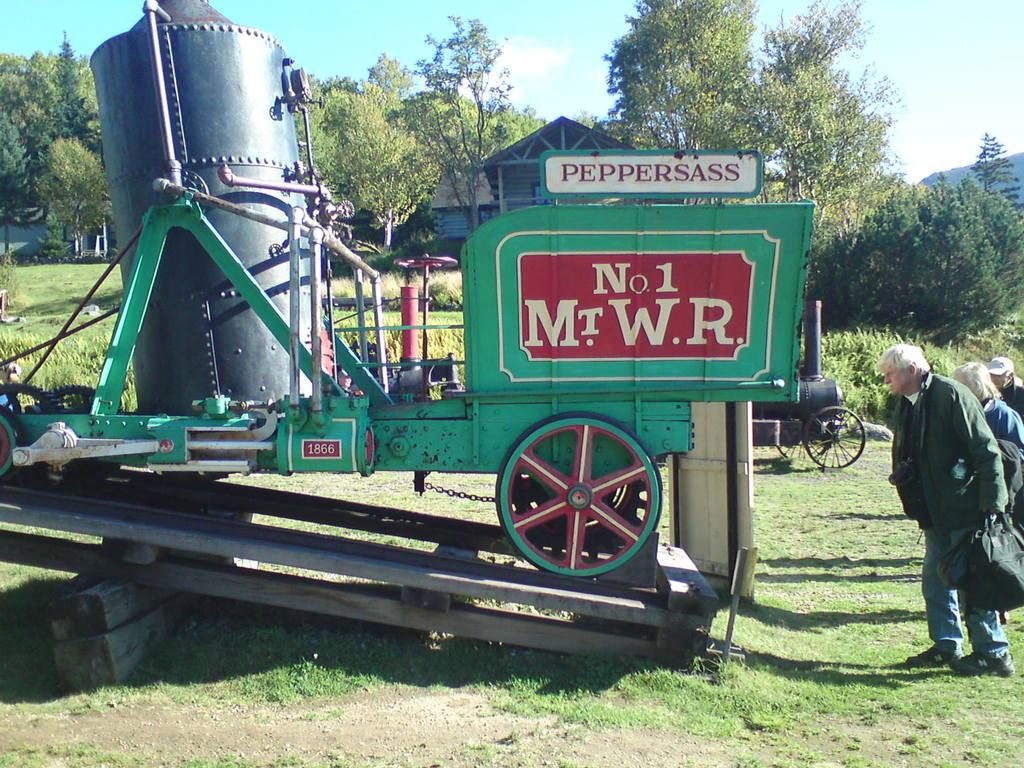What is the main object in the image? There is a machine in the image. Can you describe the appearance of the machine? The machine is green and black in color. What can be seen on the right side of the image? There are people on the right side of the image. What is visible in the background of the image? There are trees and the sky visible in the background of the image. What type of collar is the machine wearing in the image? The machine is not a living being and therefore cannot wear a collar. 